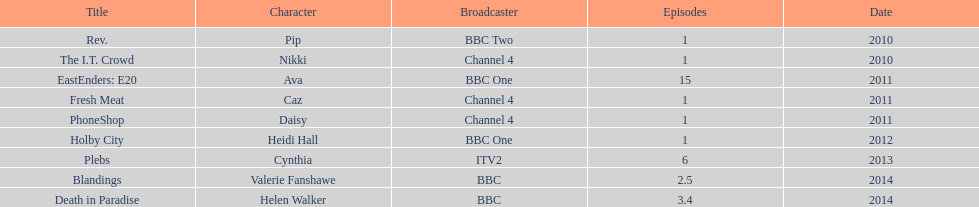How many tv appearances has this actress made? 9. 